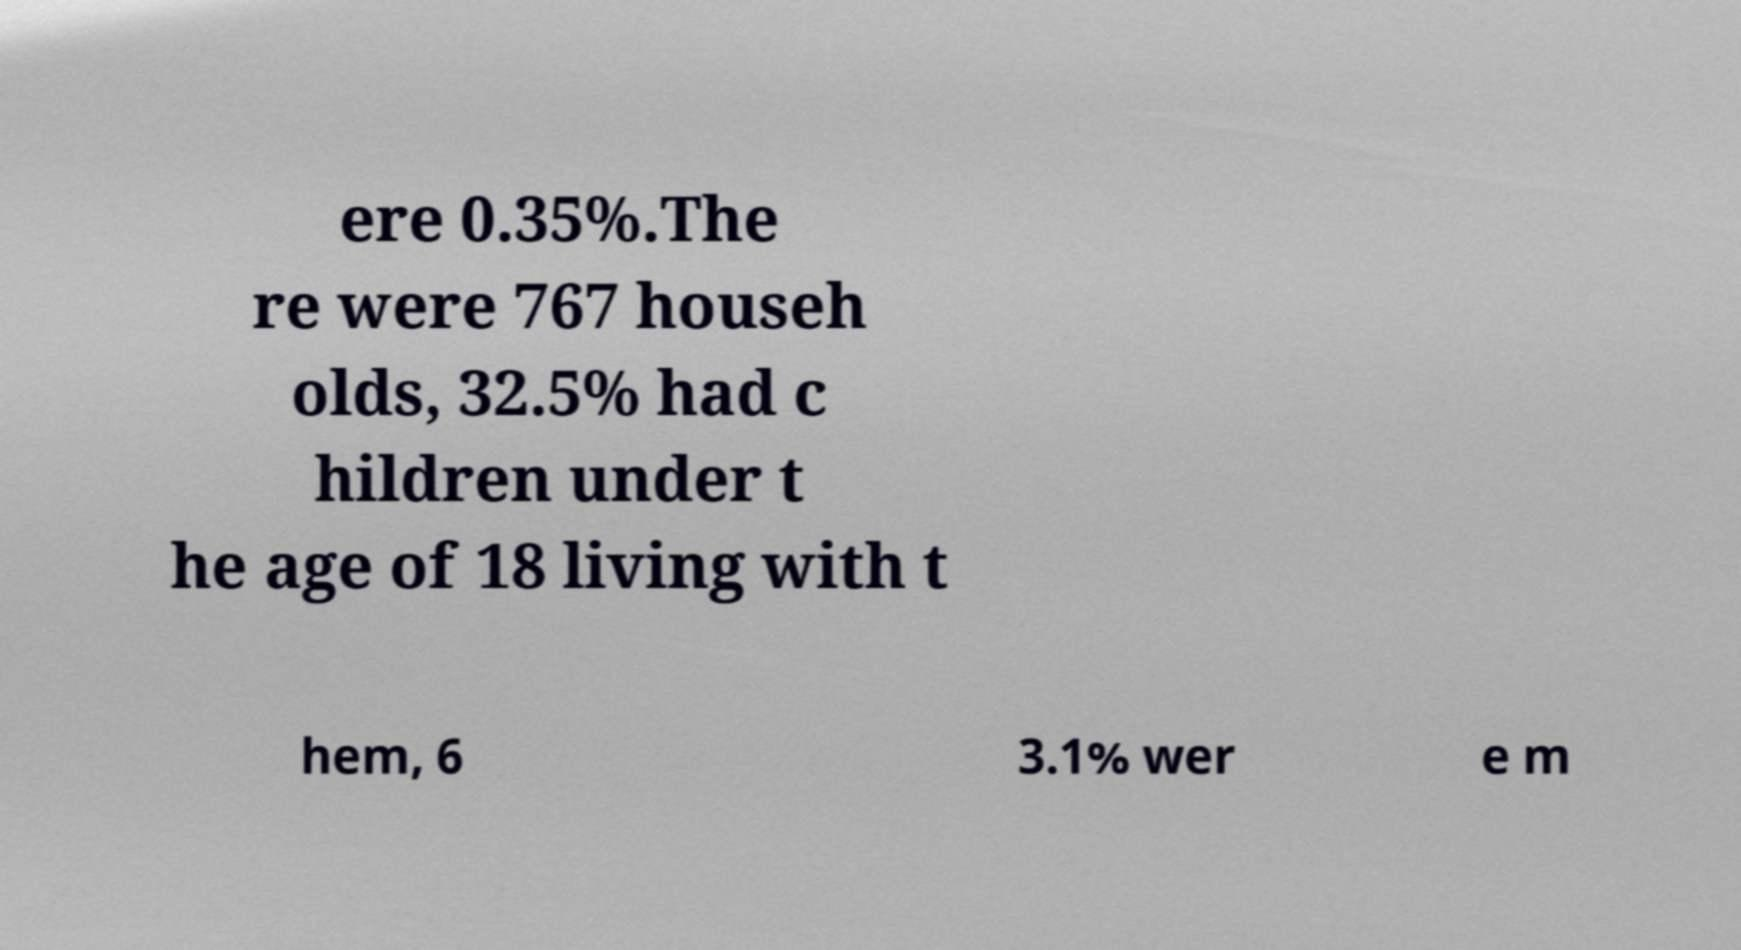Can you accurately transcribe the text from the provided image for me? ere 0.35%.The re were 767 househ olds, 32.5% had c hildren under t he age of 18 living with t hem, 6 3.1% wer e m 